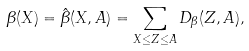<formula> <loc_0><loc_0><loc_500><loc_500>\beta ( X ) = \hat { \beta } ( X , A ) = \sum _ { X \leq Z \leq A } D _ { \beta } ( Z , A ) ,</formula> 